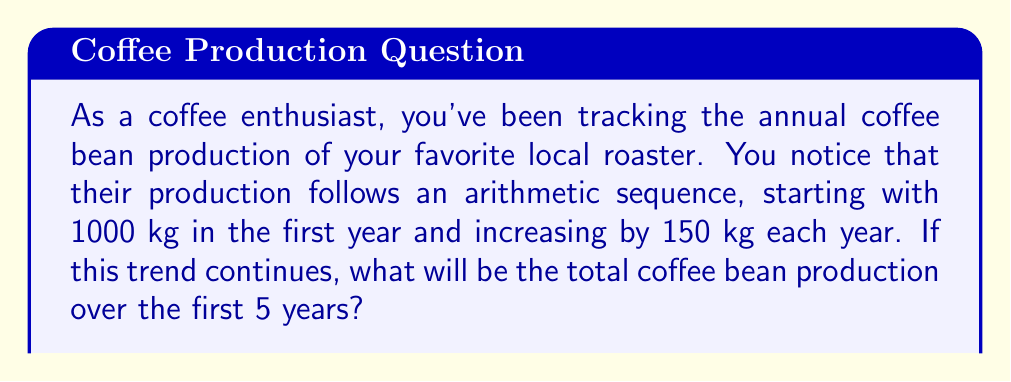Could you help me with this problem? Let's approach this step-by-step:

1) First, we need to identify the elements of the arithmetic sequence:
   - $a_1 = 1000$ (first term)
   - $d = 150$ (common difference)
   - $n = 5$ (number of terms)

2) The arithmetic sequence will be:
   Year 1: $a_1 = 1000$
   Year 2: $a_2 = 1000 + 150 = 1150$
   Year 3: $a_3 = 1150 + 150 = 1300$
   Year 4: $a_4 = 1300 + 150 = 1450$
   Year 5: $a_5 = 1450 + 150 = 1600$

3) To find the total production, we need to sum these terms. We can use the formula for the sum of an arithmetic sequence:

   $$S_n = \frac{n}{2}(a_1 + a_n)$$

   Where $S_n$ is the sum of $n$ terms, $a_1$ is the first term, and $a_n$ is the last term.

4) We know $n = 5$, $a_1 = 1000$, and $a_5 = 1600$. Let's substitute these values:

   $$S_5 = \frac{5}{2}(1000 + 1600)$$

5) Simplify:
   $$S_5 = \frac{5}{2}(2600) = 5 \times 1300 = 6500$$

Therefore, the total coffee bean production over the first 5 years will be 6500 kg.
Answer: 6500 kg 